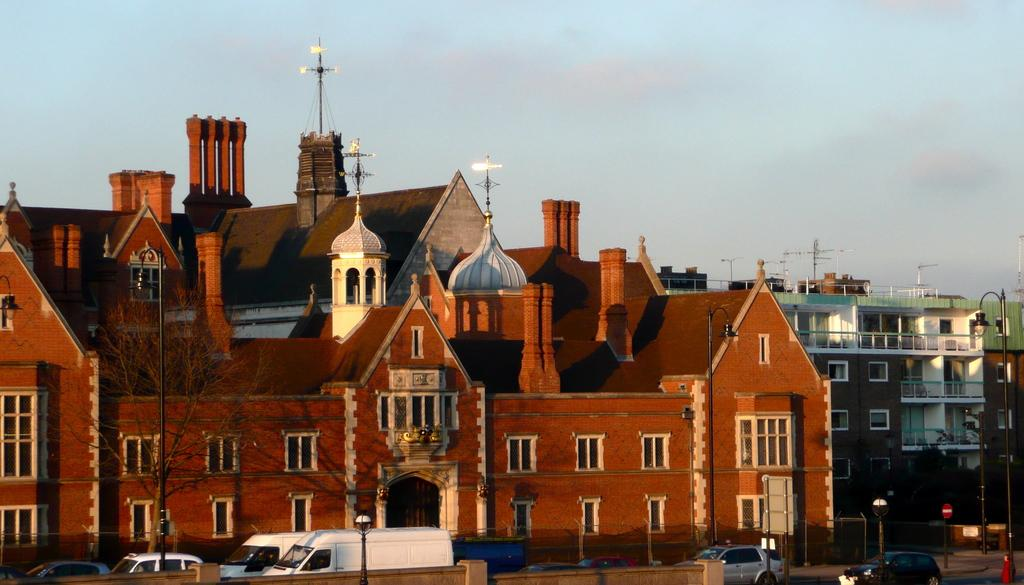What structures can be seen in the image? There are poles, lights, boards, a wall, and buildings in the image. What type of objects are present on the road in the image? There are vehicles on the road in the image. What natural element is visible in the background of the image? There is sky visible in the background of the image. Can you describe the vegetation in the image? There is a tree in the image. What type of bean is growing on the wall in the image? There is no bean growing on the wall in the image. What color is the silver object on the road in the image? There is no silver object present on the road in the image. 